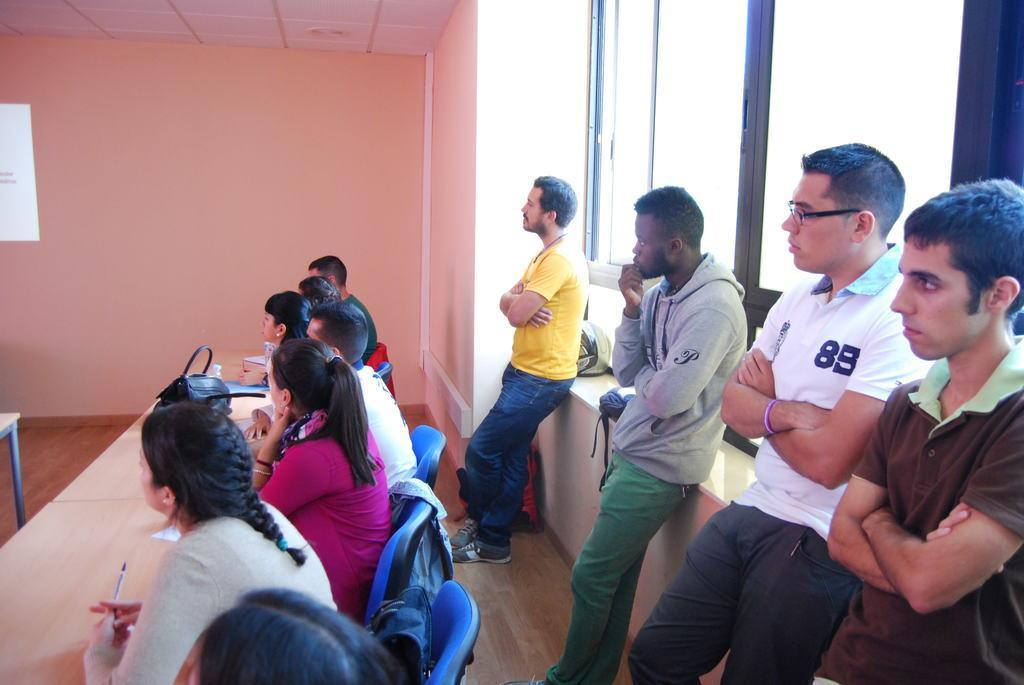Describe this image in one or two sentences. In the image we can see there are people some are sitting and some are standing. These people are wearing clothes, this is a window, helmet, bag, floor, chair, table, hand bag wall and a pen. 